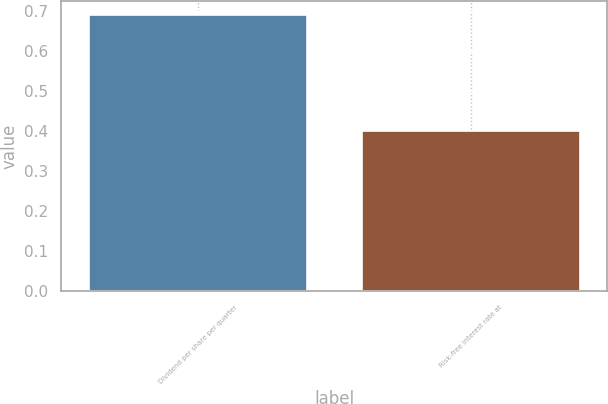Convert chart. <chart><loc_0><loc_0><loc_500><loc_500><bar_chart><fcel>Dividend per share per quarter<fcel>Risk-free interest rate at<nl><fcel>0.69<fcel>0.4<nl></chart> 